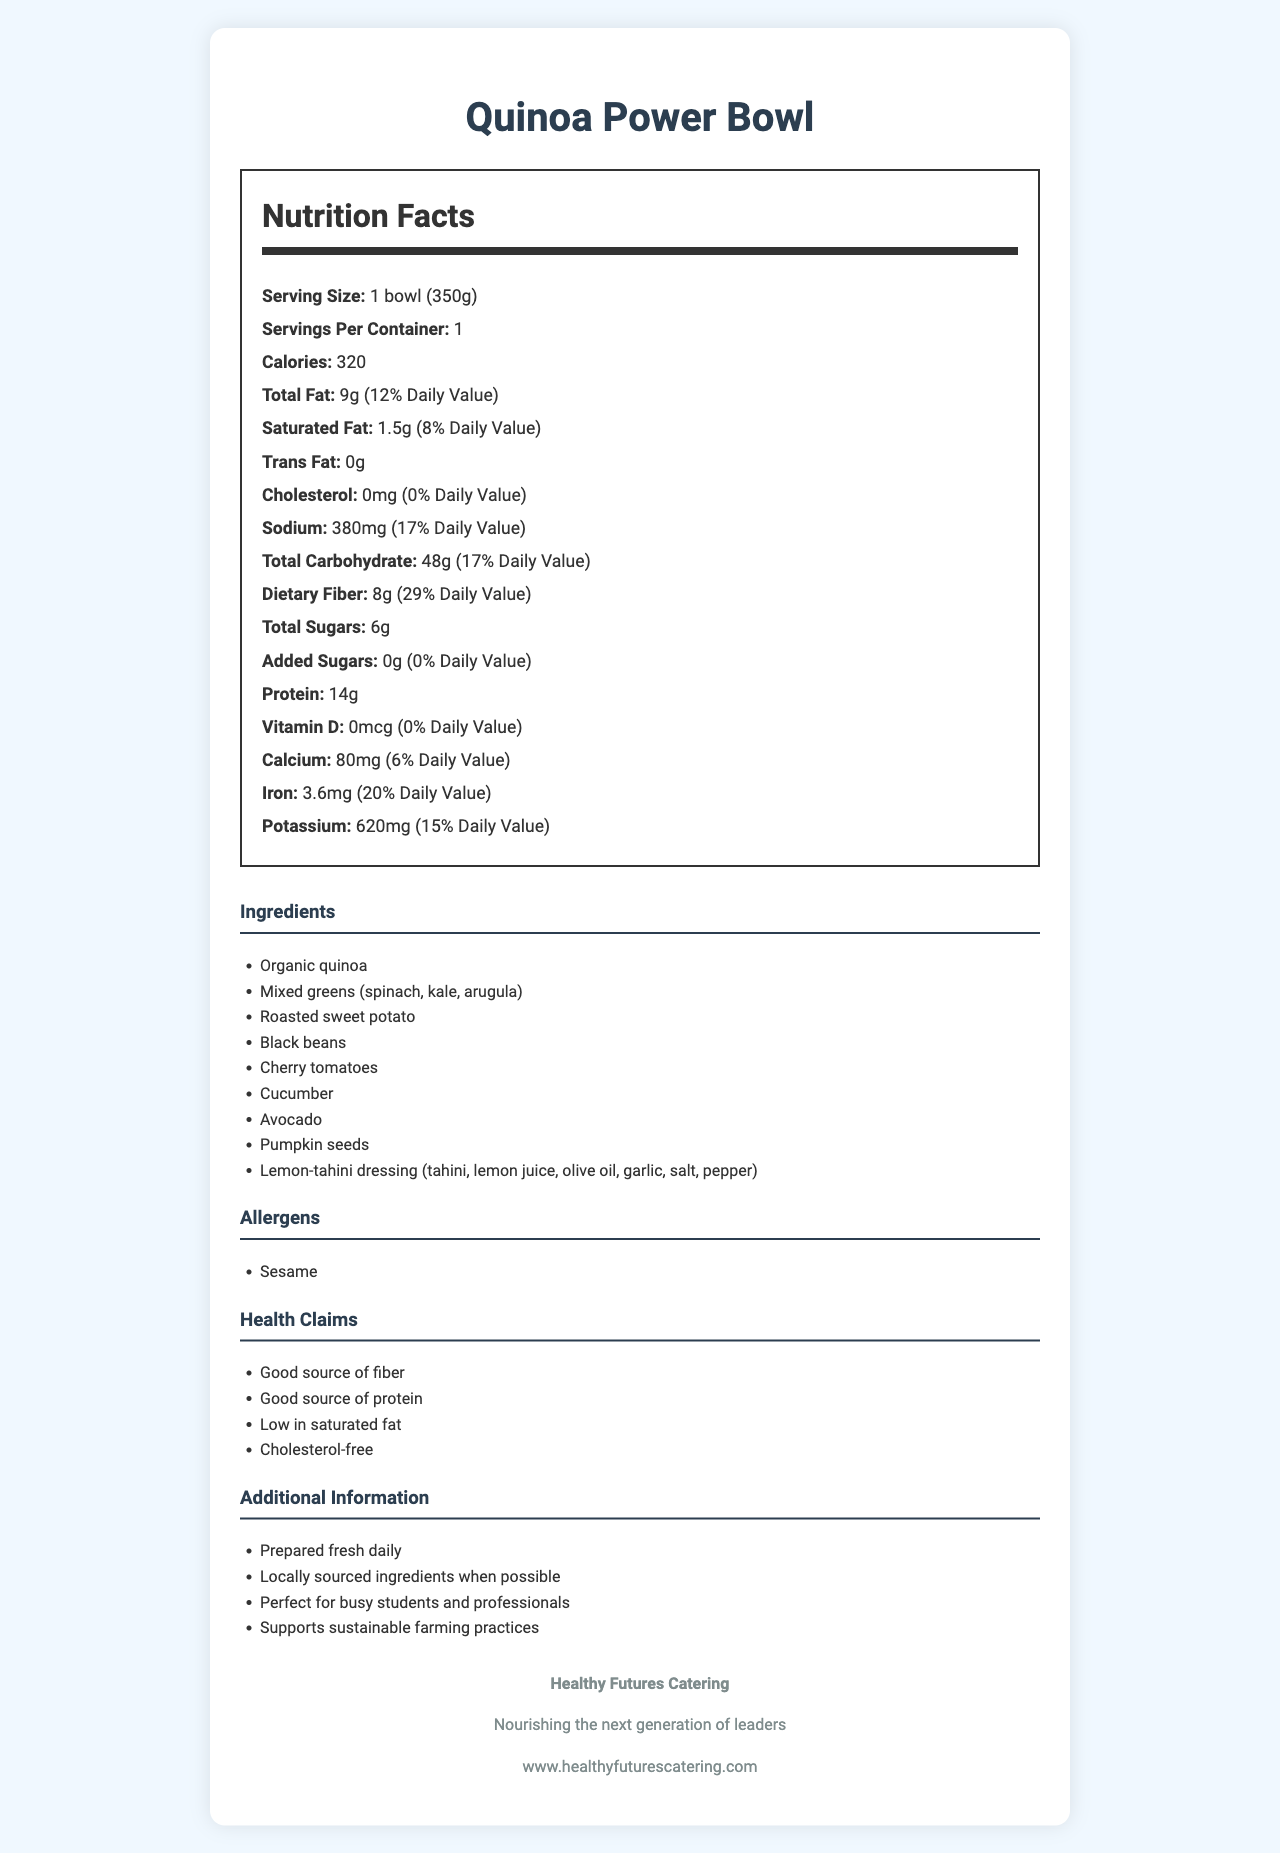what is the serving size of the Quinoa Power Bowl? The serving size is mentioned in the "Nutrition Facts" section where it states "Serving Size: 1 bowl (350g)".
Answer: 1 bowl (350g) how many calories are in one serving? The "Calories" section of the "Nutrition Facts" lists the calorie count as 320.
Answer: 320 calories what ingredients are included in the Quinoa Power Bowl? The "Ingredients" section lists all the ingredients used in the Quinoa Power Bowl.
Answer: Organic quinoa, Mixed greens (spinach, kale, arugula), Roasted sweet potato, Black beans, Cherry tomatoes, Cucumber, Avocado, Pumpkin seeds, Lemon-tahini dressing (tahini, lemon juice, olive oil, garlic, salt, pepper) how much sodium does the Quinoa Power Bowl contain? The "Sodium" section of the "Nutrition Facts" states that the sodium content is 380 mg.
Answer: 380 mg what percentage of the daily value of iron does the Quinoa Power Bowl provide? In the "Nutrition Facts" section, the "Iron" content is listed as 3.6 mg, which is 20% of the daily value.
Answer: 20% how many grams of dietary fiber are in the Quinoa Power Bowl? The "Nutrition Facts" section states that the dietary fiber content is 8 g.
Answer: 8 g is the Quinoa Power Bowl high in protein? The "Health Claims" section mentions that the product is a "Good source of protein," and the "Nutrition Facts" section lists 14 g of protein per serving.
Answer: Yes what allergens are present in the Quinoa Power Bowl? A. Dairy B. Gluten C. Sesame The "Allergens" section lists only "Sesame" as an allergen.
Answer: C. Sesame which company produces the Quinoa Power Bowl? A. Future Foods B. Healthy Futures Catering C. NutriCorp The "Company Info" section states that "Healthy Futures Catering" produces the Quinoa Power Bowl.
Answer: B. Healthy Futures Catering is the product cholesterol-free? The "Health Claims" section mentions the Quinoa Power Bowl is "Cholesterol-free," and the "Nutrition Facts" confirms there is 0 mg of cholesterol.
Answer: Yes summarize the main idea of the document. The document provides a comprehensive overview of the Quinoa Power Bowl, including nutritional data, ingredient list, potential allergens, and health benefits, as well as information about the company's practices and goals in providing healthy food options.
Answer: The document is a nutrition facts label for the Quinoa Power Bowl, a nutritious and low-calorie lunch option served at student-business owner networking events. It includes detailed nutritional information, ingredients, allergens, health claims, additional information about the product, and company details. what is the recommended daily value percentage for saturated fat in this product? The "Nutrition Facts" section states that the saturated fat content is 1.5 g, which is 8% of the daily value.
Answer: 8% does the Quinoa Power Bowl contain any added sugars? The "Nutrition Facts" section shows "Added Sugars: 0 g", indicating there are no added sugars in the product.
Answer: No what is the power bowl’s primary source of protein? The document lists various ingredients, but it does not specify which ingredient is the primary source of protein.
Answer: Cannot be determined 